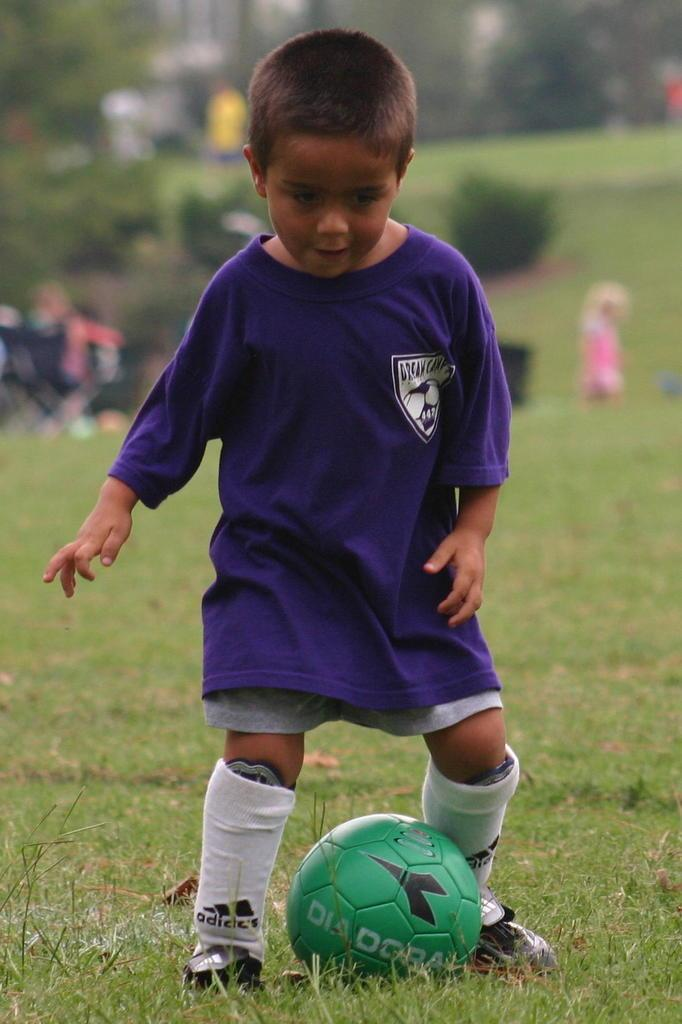Who is the main subject in the image? There is a boy in the image. What is the boy doing in the image? The boy is playing with a ball. What type of surface is the boy playing on? There is grass in the image. What other natural elements can be seen in the image? There are trees in the image. What type of pump is visible in the image? There is no pump present in the image. What organization or committee is responsible for the boy's playtime in the image? There is no organization or committee mentioned or implied in the image. 